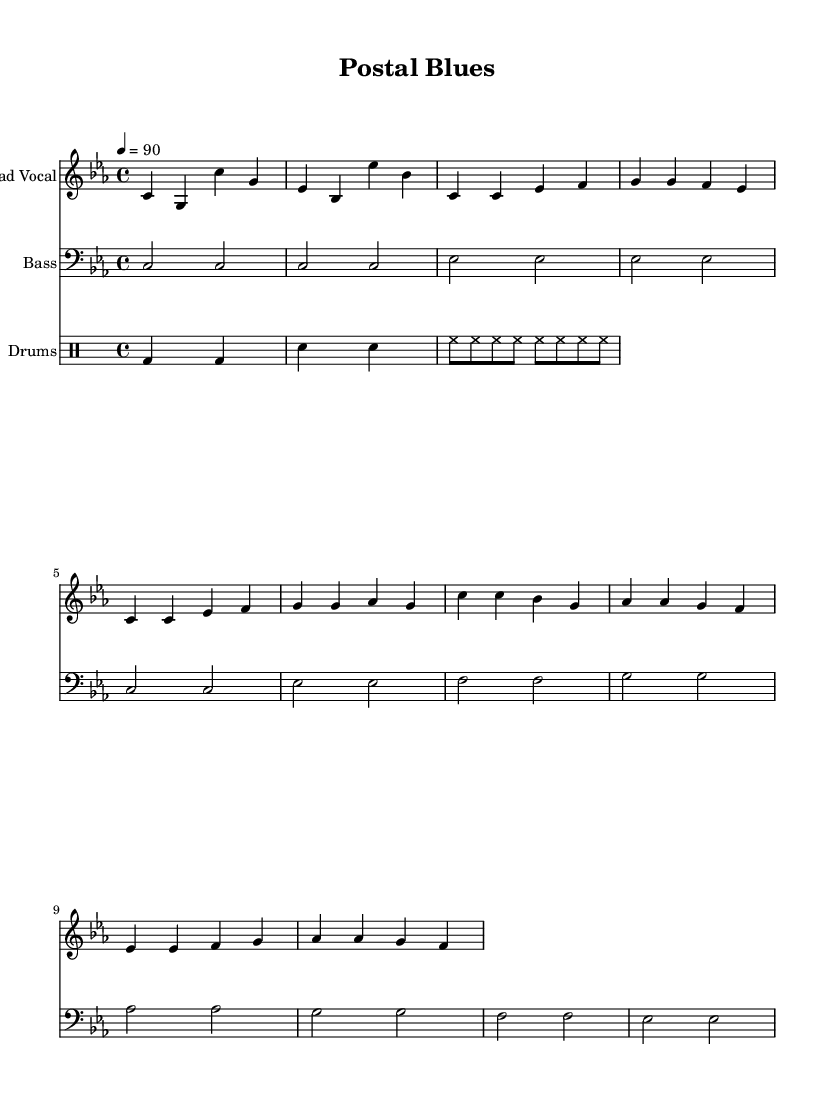What is the key signature of this music? The key signature is C minor, which has three flats (B flat, E flat, A flat). This can be determined by looking at the key signature at the beginning of the staff where the music is written.
Answer: C minor What is the time signature of this music? The time signature is 4/4, meaning there are four beats in a measure and the quarter note gets one beat. This is indicated at the beginning of the score.
Answer: 4/4 What is the tempo marking for this piece? The tempo marking indicates a speed of 90 beats per minute, which is noted in beats per minute (BPM) next to the word tempo at the beginning of the score.
Answer: 90 How many measures are present in the chorus section? The chorus section consists of 4 measures, which can be counted from the notation given in the music, specifically looking at the section labeled as the chorus.
Answer: 4 What type of drum is indicated by the "bd" notation? The "bd" notation refers to the bass drum, which is indicated within the drummode section of the music notation.
Answer: Bass drum What is the primary theme of the lyrics? The primary theme of the lyrics addresses the experiences and challenges faced by postal workers and government employees, as highlighted in the text of the lyrics.
Answer: Postal workers' challenges What is the mood conveyed by the melody based on the key? The mood conveyed by the melody is generally perceived as somber or introspective, which is often associated with minor keys such as C minor.
Answer: Somber 